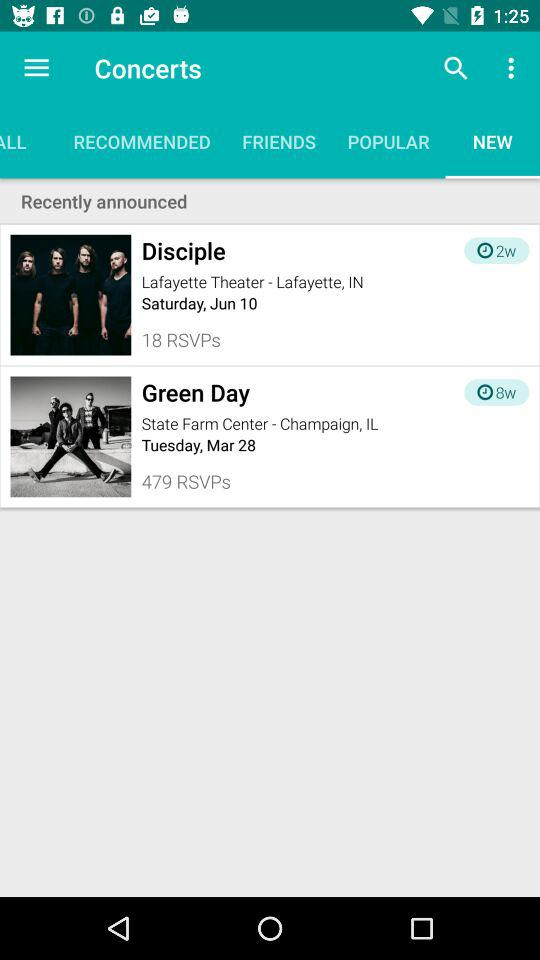How many weeks are left for concert disciple?
When the provided information is insufficient, respond with <no answer>. <no answer> 